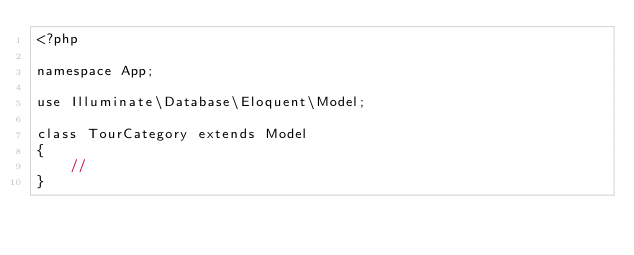Convert code to text. <code><loc_0><loc_0><loc_500><loc_500><_PHP_><?php

namespace App;

use Illuminate\Database\Eloquent\Model;

class TourCategory extends Model
{
    //
}
</code> 